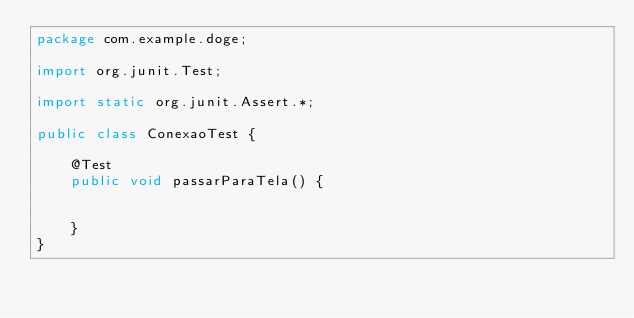Convert code to text. <code><loc_0><loc_0><loc_500><loc_500><_Java_>package com.example.doge;

import org.junit.Test;

import static org.junit.Assert.*;

public class ConexaoTest {

    @Test
    public void passarParaTela() {


    }
}</code> 